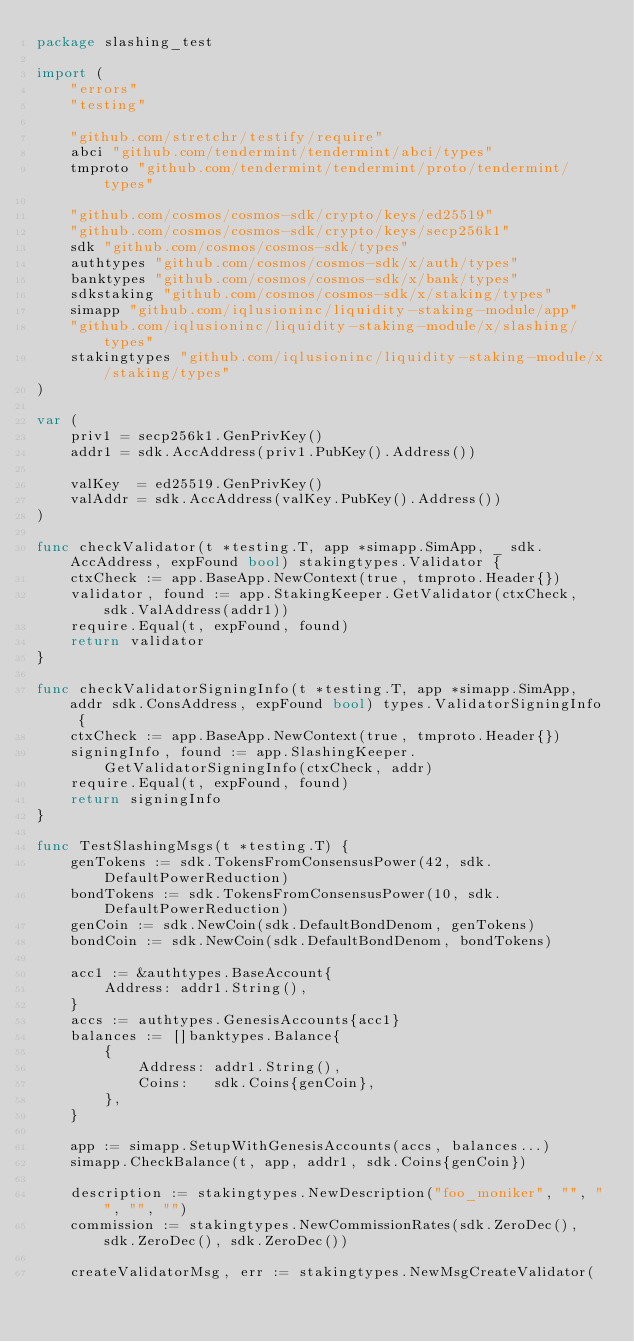<code> <loc_0><loc_0><loc_500><loc_500><_Go_>package slashing_test

import (
	"errors"
	"testing"

	"github.com/stretchr/testify/require"
	abci "github.com/tendermint/tendermint/abci/types"
	tmproto "github.com/tendermint/tendermint/proto/tendermint/types"

	"github.com/cosmos/cosmos-sdk/crypto/keys/ed25519"
	"github.com/cosmos/cosmos-sdk/crypto/keys/secp256k1"
	sdk "github.com/cosmos/cosmos-sdk/types"
	authtypes "github.com/cosmos/cosmos-sdk/x/auth/types"
	banktypes "github.com/cosmos/cosmos-sdk/x/bank/types"
	sdkstaking "github.com/cosmos/cosmos-sdk/x/staking/types"
	simapp "github.com/iqlusioninc/liquidity-staking-module/app"
	"github.com/iqlusioninc/liquidity-staking-module/x/slashing/types"
	stakingtypes "github.com/iqlusioninc/liquidity-staking-module/x/staking/types"
)

var (
	priv1 = secp256k1.GenPrivKey()
	addr1 = sdk.AccAddress(priv1.PubKey().Address())

	valKey  = ed25519.GenPrivKey()
	valAddr = sdk.AccAddress(valKey.PubKey().Address())
)

func checkValidator(t *testing.T, app *simapp.SimApp, _ sdk.AccAddress, expFound bool) stakingtypes.Validator {
	ctxCheck := app.BaseApp.NewContext(true, tmproto.Header{})
	validator, found := app.StakingKeeper.GetValidator(ctxCheck, sdk.ValAddress(addr1))
	require.Equal(t, expFound, found)
	return validator
}

func checkValidatorSigningInfo(t *testing.T, app *simapp.SimApp, addr sdk.ConsAddress, expFound bool) types.ValidatorSigningInfo {
	ctxCheck := app.BaseApp.NewContext(true, tmproto.Header{})
	signingInfo, found := app.SlashingKeeper.GetValidatorSigningInfo(ctxCheck, addr)
	require.Equal(t, expFound, found)
	return signingInfo
}

func TestSlashingMsgs(t *testing.T) {
	genTokens := sdk.TokensFromConsensusPower(42, sdk.DefaultPowerReduction)
	bondTokens := sdk.TokensFromConsensusPower(10, sdk.DefaultPowerReduction)
	genCoin := sdk.NewCoin(sdk.DefaultBondDenom, genTokens)
	bondCoin := sdk.NewCoin(sdk.DefaultBondDenom, bondTokens)

	acc1 := &authtypes.BaseAccount{
		Address: addr1.String(),
	}
	accs := authtypes.GenesisAccounts{acc1}
	balances := []banktypes.Balance{
		{
			Address: addr1.String(),
			Coins:   sdk.Coins{genCoin},
		},
	}

	app := simapp.SetupWithGenesisAccounts(accs, balances...)
	simapp.CheckBalance(t, app, addr1, sdk.Coins{genCoin})

	description := stakingtypes.NewDescription("foo_moniker", "", "", "", "")
	commission := stakingtypes.NewCommissionRates(sdk.ZeroDec(), sdk.ZeroDec(), sdk.ZeroDec())

	createValidatorMsg, err := stakingtypes.NewMsgCreateValidator(</code> 